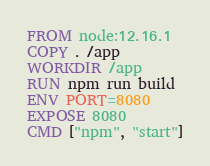Convert code to text. <code><loc_0><loc_0><loc_500><loc_500><_Dockerfile_>FROM node:12.16.1
COPY . /app
WORKDIR /app
RUN npm run build
ENV PORT=8080
EXPOSE 8080
CMD ["npm", "start"]</code> 